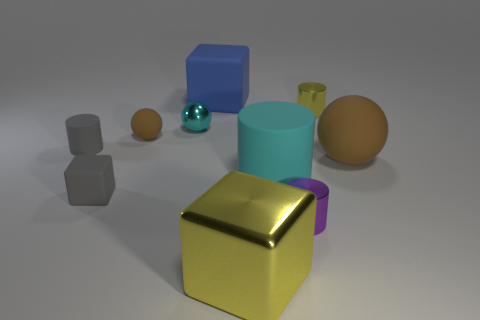Does the tiny matte cylinder have the same color as the small cube?
Make the answer very short. Yes. Is the material of the big cylinder the same as the tiny yellow cylinder?
Your response must be concise. No. What is the shape of the large metal object?
Give a very brief answer. Cube. There is a matte cube behind the rubber ball that is on the left side of the large blue rubber cube; what number of blocks are in front of it?
Your answer should be very brief. 2. There is another rubber object that is the same shape as the cyan rubber object; what is its color?
Give a very brief answer. Gray. There is a object that is to the left of the block that is to the left of the big block behind the small gray block; what shape is it?
Give a very brief answer. Cylinder. What size is the metallic object that is both in front of the gray cylinder and to the right of the big cyan cylinder?
Give a very brief answer. Small. Is the number of big shiny cubes less than the number of large things?
Your answer should be compact. Yes. There is a object that is right of the tiny yellow thing; what is its size?
Ensure brevity in your answer.  Large. What is the shape of the metallic thing that is in front of the yellow metallic cylinder and on the right side of the big yellow thing?
Provide a short and direct response. Cylinder. 